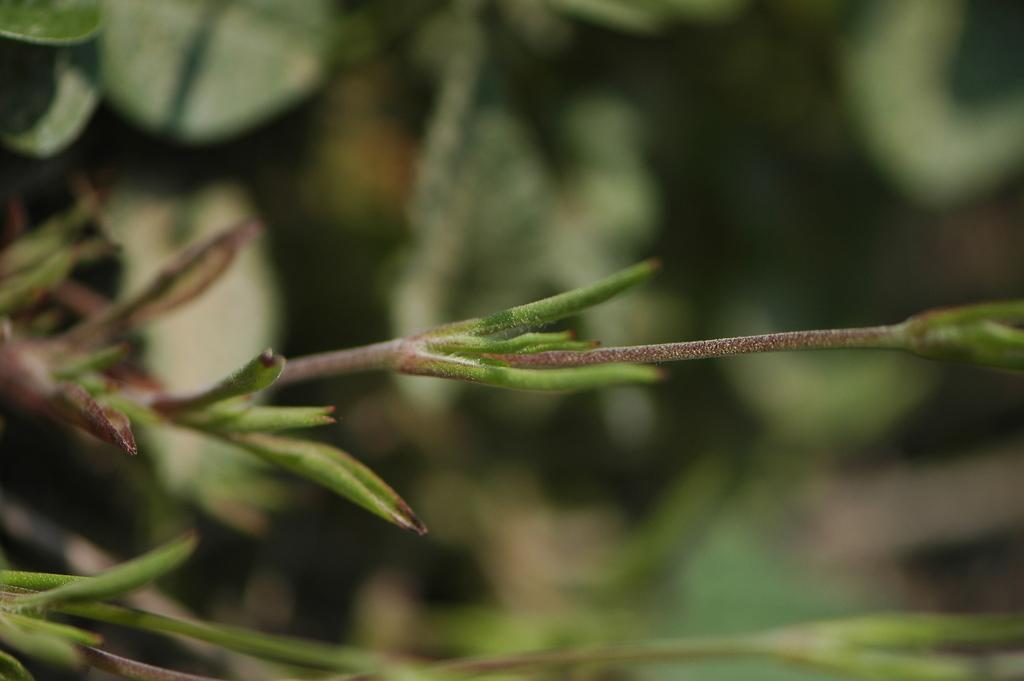What is the main subject in the foreground of the image? There is a stem of a plant in the foreground of the image. What can be observed about the background of the image? The background of the image is blurry. What type of sweater is being worn by the plant in the image? There is no sweater present in the image, as the subject is a plant stem. 